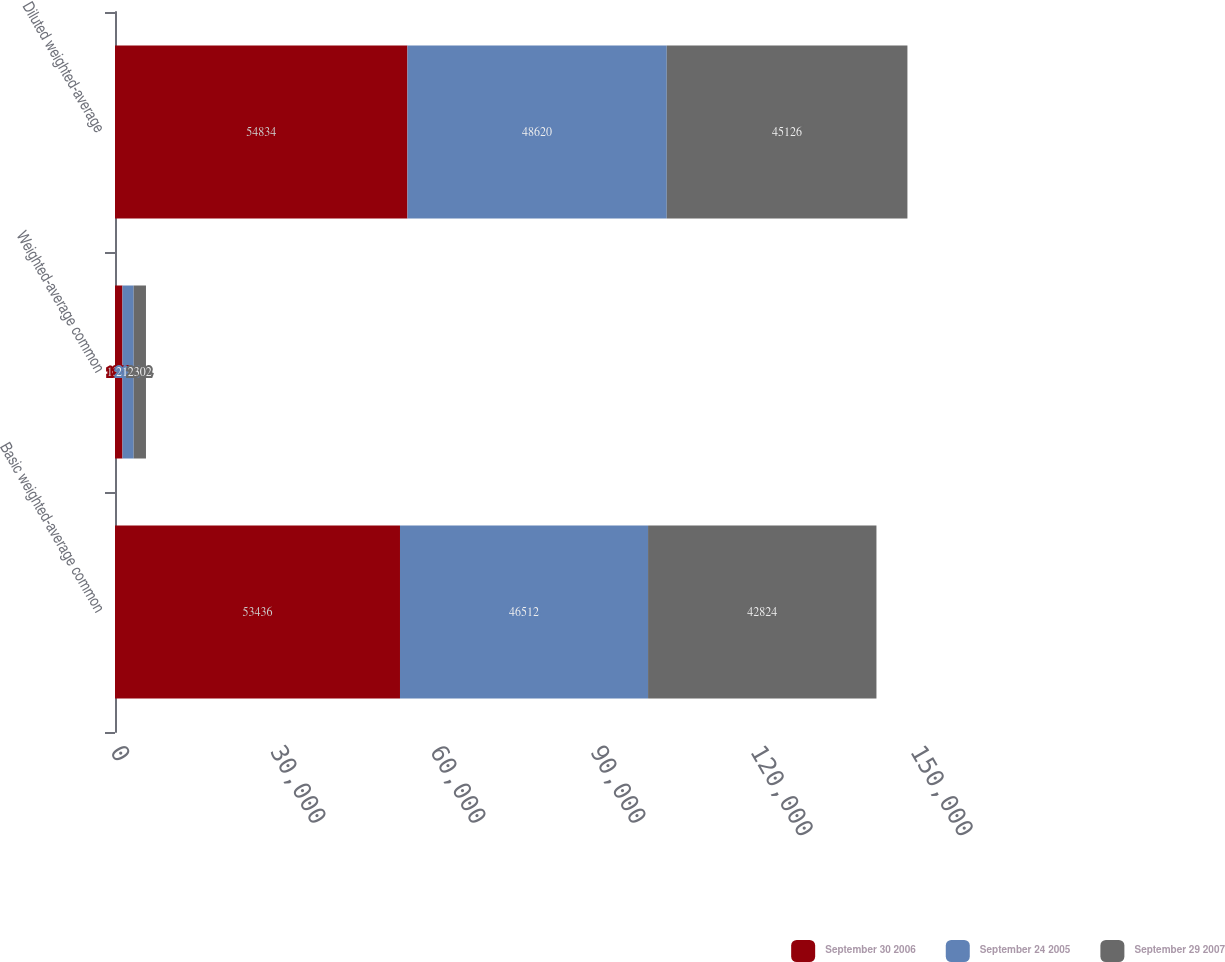Convert chart to OTSL. <chart><loc_0><loc_0><loc_500><loc_500><stacked_bar_chart><ecel><fcel>Basic weighted-average common<fcel>Weighted-average common<fcel>Diluted weighted-average<nl><fcel>September 30 2006<fcel>53436<fcel>1398<fcel>54834<nl><fcel>September 24 2005<fcel>46512<fcel>2108<fcel>48620<nl><fcel>September 29 2007<fcel>42824<fcel>2302<fcel>45126<nl></chart> 